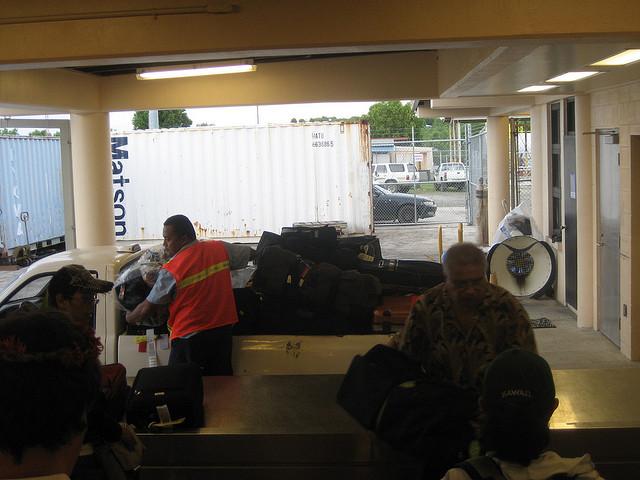Why is the man wearing an orange vest?
Concise answer only. Safety. How many people are in this scene?
Give a very brief answer. 5. Where does this scene likely take place?
Answer briefly. Airport. 